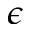<formula> <loc_0><loc_0><loc_500><loc_500>\epsilon</formula> 